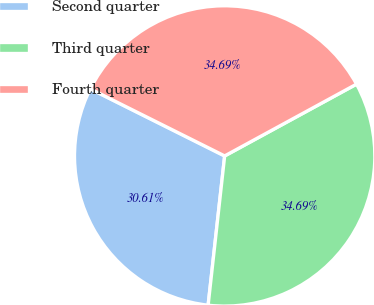Convert chart to OTSL. <chart><loc_0><loc_0><loc_500><loc_500><pie_chart><fcel>Second quarter<fcel>Third quarter<fcel>Fourth quarter<nl><fcel>30.61%<fcel>34.69%<fcel>34.69%<nl></chart> 